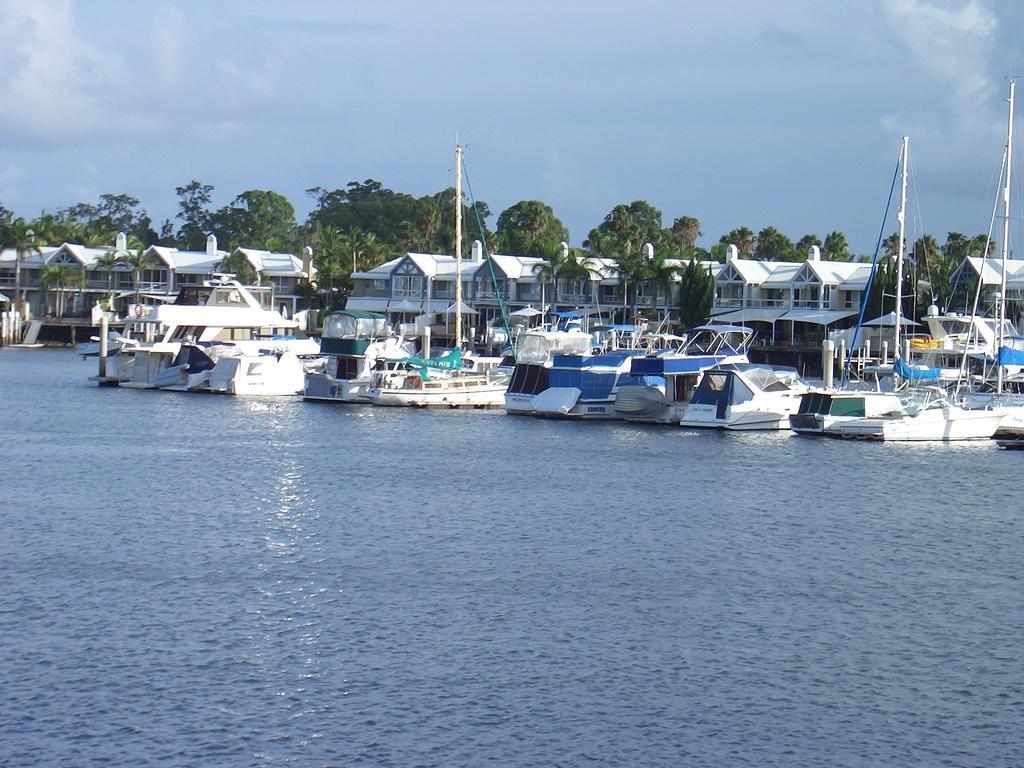In one or two sentences, can you explain what this image depicts? This is an outside view. At the bottom, I can see the water. In the middle of the image there are many boats, buildings, trees and poles. At the top of the image I can see the sky. 